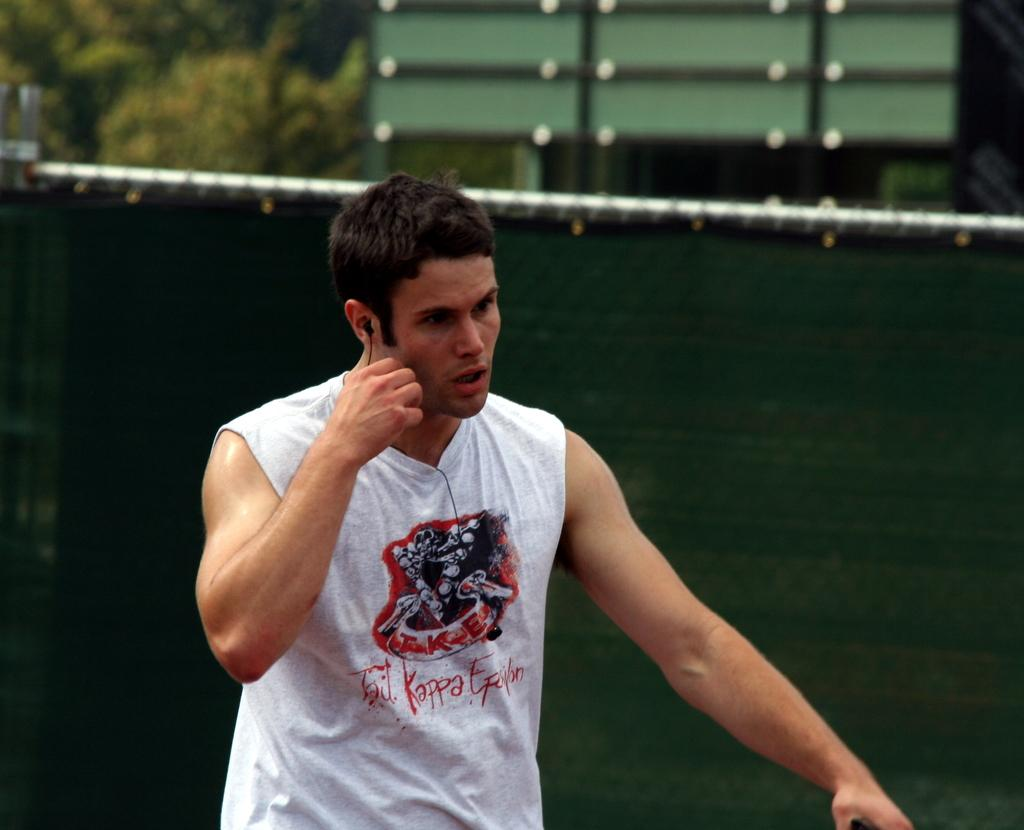<image>
Summarize the visual content of the image. a man a tshirt that has kappa on it 